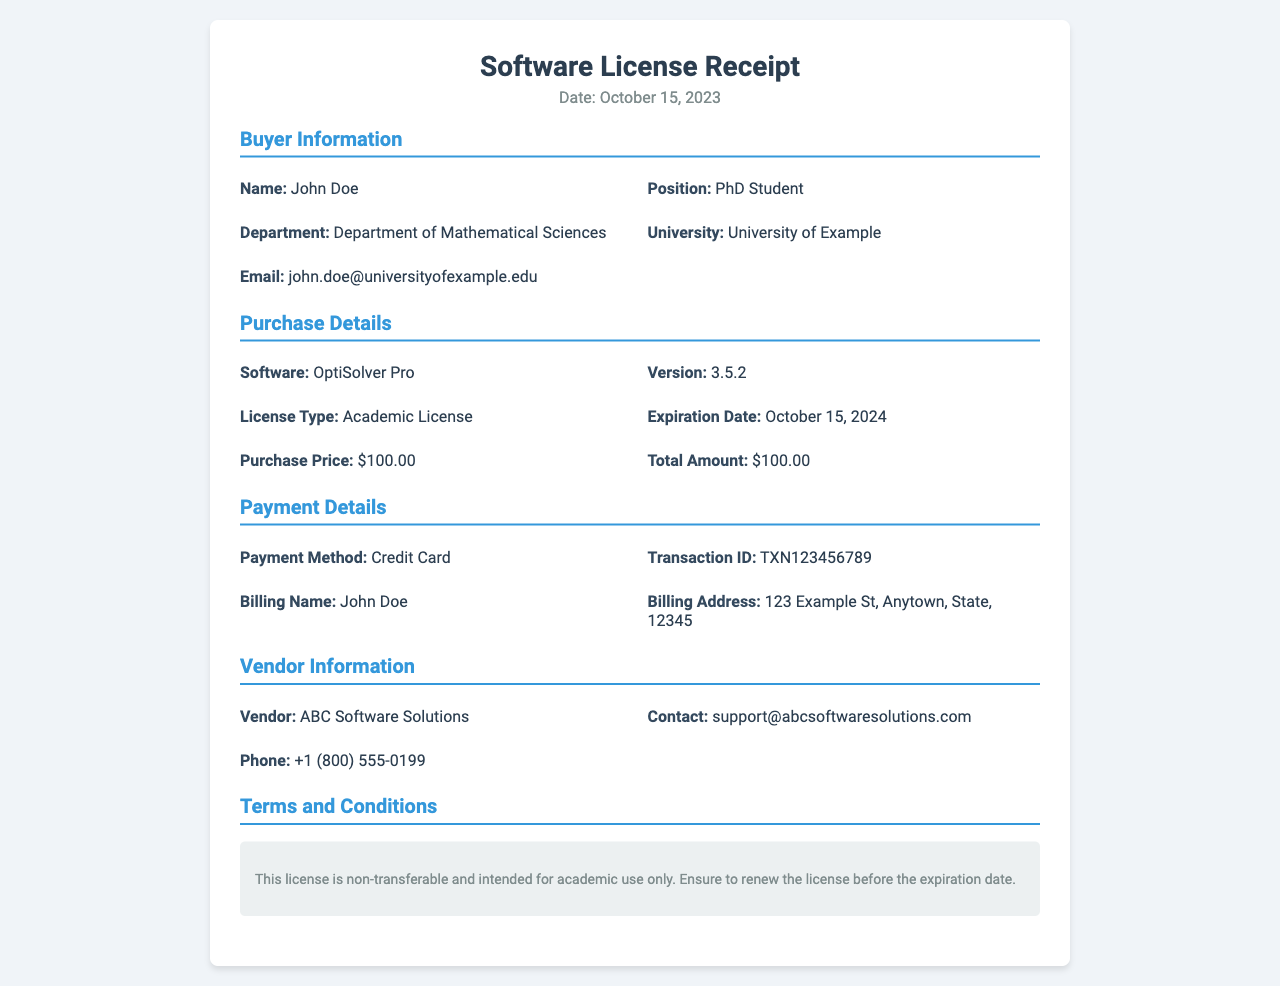What is the software purchased? The software purchased is mentioned clearly in the document under Purchase Details as "OptiSolver Pro."
Answer: OptiSolver Pro What is the version number of the software? The version number is specified in the Purchase Details section of the document, indicating the latest version of the software.
Answer: 3.5.2 What is the expiration date of the license? The expiration date is provided in the Purchase Details and indicates how long the license is valid for use.
Answer: October 15, 2024 Who is the buyer? The buyer's details are provided under Buyer Information, specifically naming the individual who made the purchase.
Answer: John Doe What was the total amount paid? The total amount is stated in the Purchase Details and represents the amount charged for the software license.
Answer: $100.00 What is the payment method used for the purchase? The payment method is specified in the Payment Details section and indicates how the transaction was processed.
Answer: Credit Card What name is on the billing account? The billing name is included in the Payment Details section, reflecting the purchaser's name as recorded.
Answer: John Doe What is the vendor's contact email? The vendor's contact email is provided in the Vendor Information section for any follow-up or assistance needed.
Answer: support@abcsoftwaresolutions.com What type of license was purchased? The type of license is indicated in the Purchase Details, reflecting the intended use of the software.
Answer: Academic License 